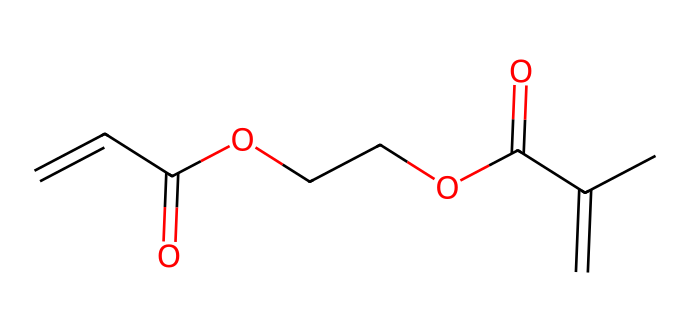What is the total number of carbon atoms in the molecule? Count the number of 'C' in the SMILES representation. In this structure, there are 8 carbon atoms indicated.
Answer: 8 How many double bonds are present in the chemical structure? Look for the '=' symbols in the SMILES; they indicate double bonds. In this case, there are 2 double bonds present.
Answer: 2 What functional groups are present in this molecule? Analyze the SMILES for identifiable groups: the presence of 'C=O' suggests carbonyl groups, and 'OCC' indicates an ether or ester linkage. Two carbonyl and one ether functional groups are present.
Answer: carbonyl and ether What type of polymerization is suggested by the acrylate monomers? The presence of polymerizable double bonds (C=C) in the structure indicates that it can undergo addition polymerization, a characteristic of acrylate monomers.
Answer: addition polymerization What role do the acrylate monomers play in UV-curable coating resins? Acrylate monomers provide reactive sites that cross-link upon exposure to UV light, forming a solid matrix for coatings. This indicates their role as primary reactive components in the resin formulation.
Answer: cross-linking agents How does the presence of the ester linkage affect the chemical properties? The ester linkages can influence the flexibility, adhesion, and hardness of the cured resin, contributing to improved durability and performance in the coating.
Answer: increases flexibility and adhesion potential 